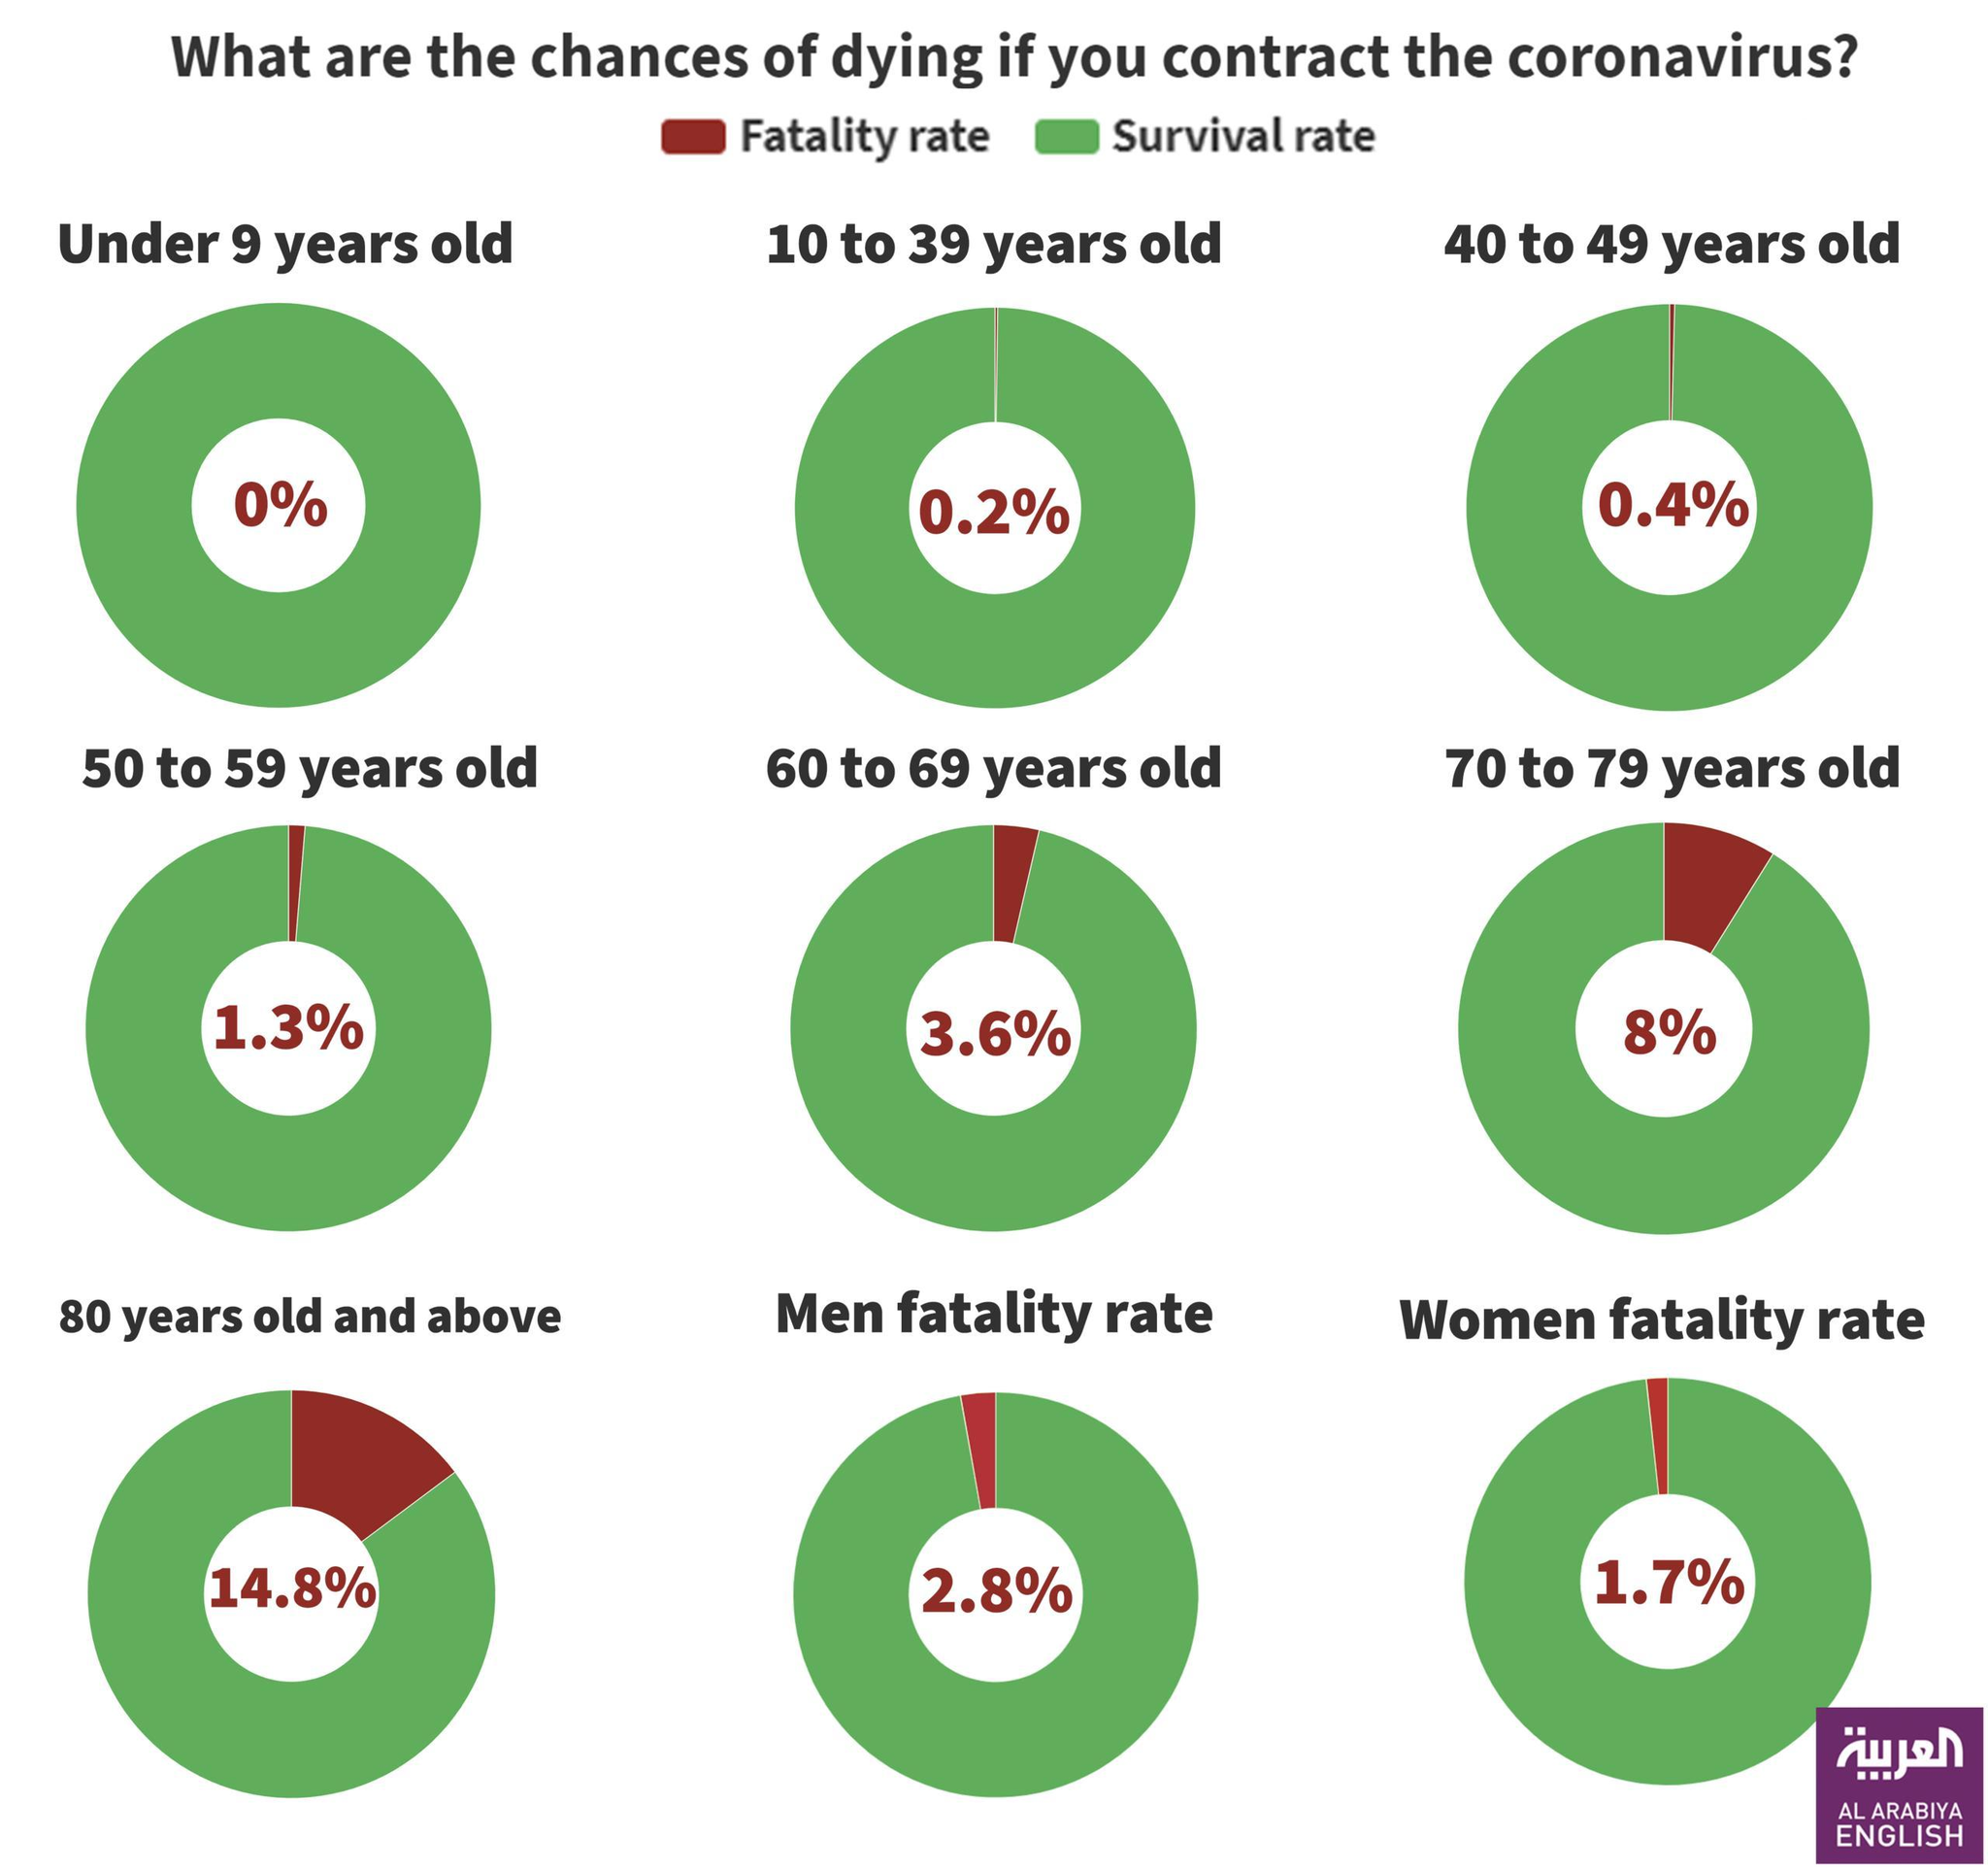What is the color code given to survival rate- red, yellow, green, blue?
Answer the question with a short phrase. green People of which age group are in high risk due to corona? 80 years old and above What is the fatality rate of people aged above or equal to 60 and below 70? 3.6% what is the survival rate of 50 to 59 years old? 98.7 what is the survival rate of 40 to 49 years old? 99.6 How much is the fatality rate of males greater than females? 1.1 People belonging to which age group have fatality rate of 3.6%? 60 to 69 years old People belonging to which age group have 99.8% of survival rate? 10 to 39 years old What is the fatality rate of Males? 2.8% People of which age group has the second-highest risk in the corona? 70 to 79 years old 